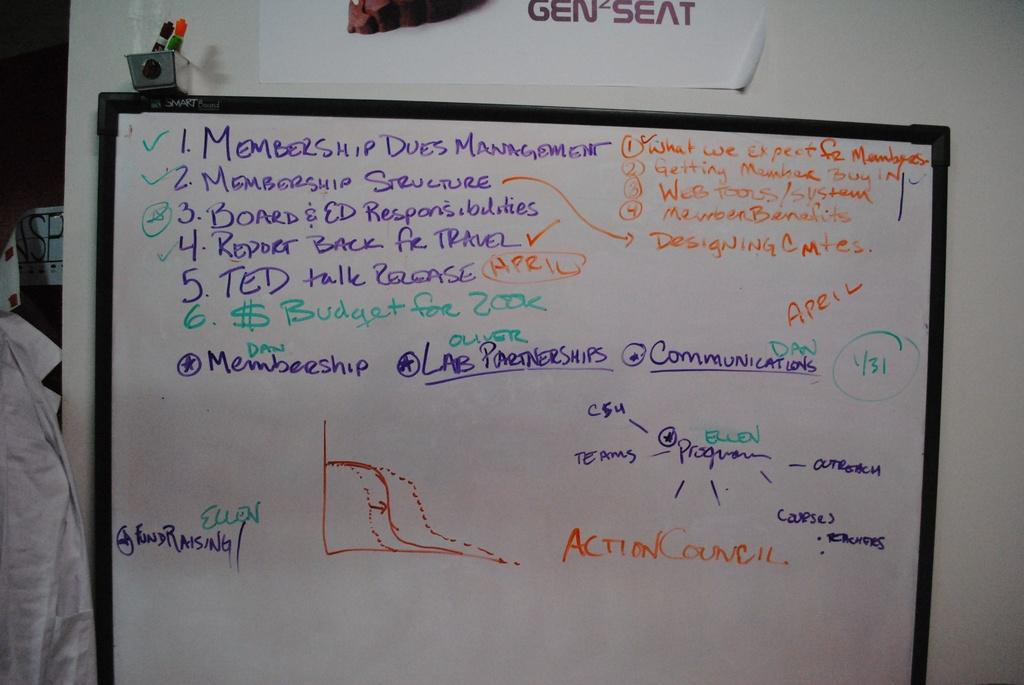<image>
Give a short and clear explanation of the subsequent image. A list on a white board starts with membership dues management. 